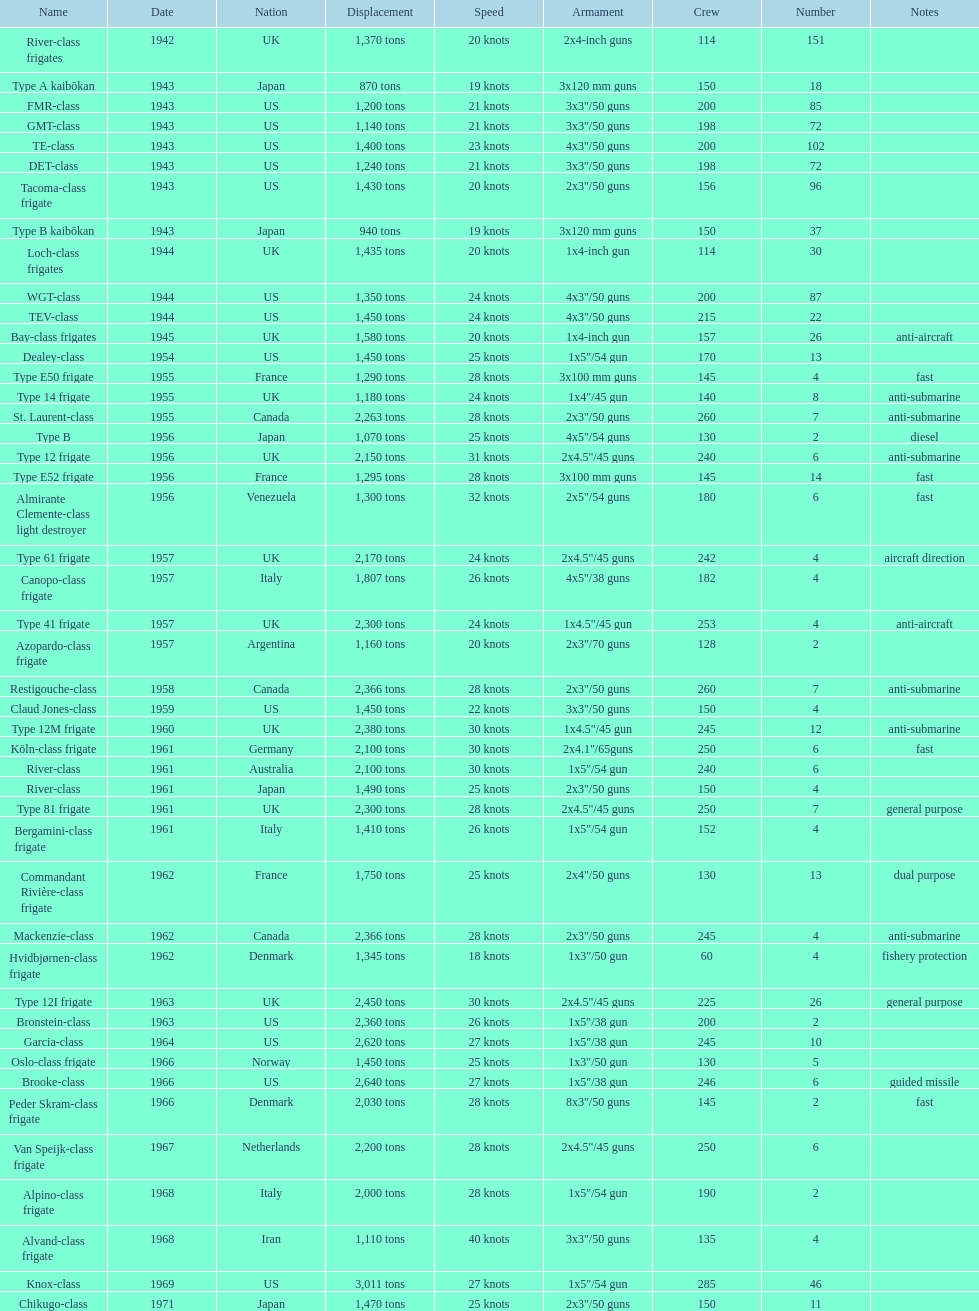What is the highest velocity? 40 knots. 